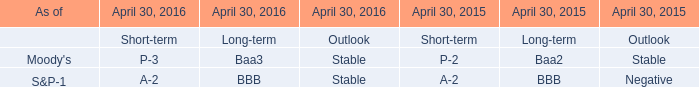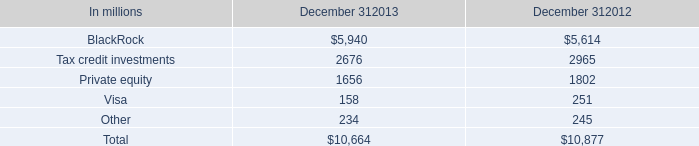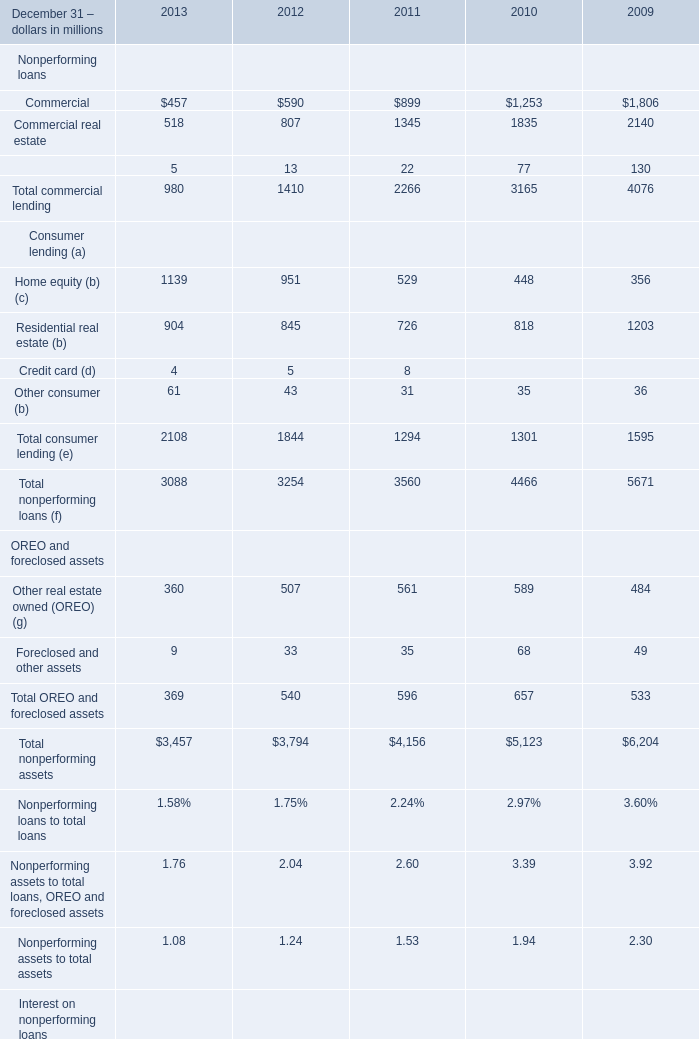What is the proportion of all Consumer lending (a) that are greater than 400 to the total amount of Consumer lending (a), in 2013? 
Computations: ((1139 + 904) / (((1139 + 904) + 4) + 61))
Answer: 0.96917. 